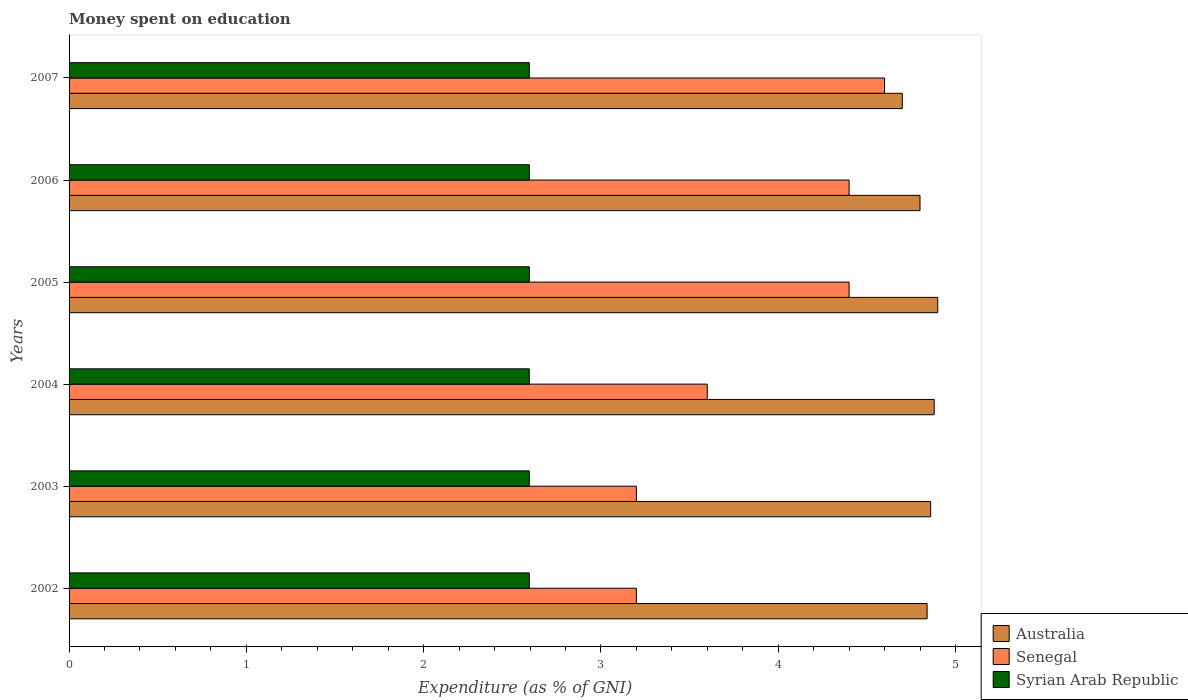How many different coloured bars are there?
Ensure brevity in your answer.  3. Are the number of bars per tick equal to the number of legend labels?
Your answer should be compact. Yes. How many bars are there on the 5th tick from the top?
Ensure brevity in your answer.  3. How many bars are there on the 5th tick from the bottom?
Keep it short and to the point. 3. In how many cases, is the number of bars for a given year not equal to the number of legend labels?
Keep it short and to the point. 0. What is the amount of money spent on education in Syrian Arab Republic in 2004?
Keep it short and to the point. 2.6. Across all years, what is the maximum amount of money spent on education in Australia?
Make the answer very short. 4.9. Across all years, what is the minimum amount of money spent on education in Syrian Arab Republic?
Offer a terse response. 2.6. In which year was the amount of money spent on education in Australia maximum?
Keep it short and to the point. 2005. What is the total amount of money spent on education in Australia in the graph?
Ensure brevity in your answer.  28.98. What is the difference between the amount of money spent on education in Senegal in 2004 and that in 2006?
Provide a succinct answer. -0.8. What is the average amount of money spent on education in Syrian Arab Republic per year?
Your answer should be compact. 2.6. In the year 2004, what is the difference between the amount of money spent on education in Syrian Arab Republic and amount of money spent on education in Australia?
Your answer should be compact. -2.28. What is the ratio of the amount of money spent on education in Senegal in 2003 to that in 2004?
Provide a short and direct response. 0.89. What is the difference between the highest and the second highest amount of money spent on education in Australia?
Your answer should be compact. 0.02. What is the difference between the highest and the lowest amount of money spent on education in Australia?
Provide a short and direct response. 0.2. What does the 2nd bar from the top in 2003 represents?
Provide a succinct answer. Senegal. What does the 2nd bar from the bottom in 2004 represents?
Your response must be concise. Senegal. Are all the bars in the graph horizontal?
Offer a terse response. Yes. How many years are there in the graph?
Give a very brief answer. 6. What is the difference between two consecutive major ticks on the X-axis?
Your response must be concise. 1. Are the values on the major ticks of X-axis written in scientific E-notation?
Provide a short and direct response. No. Does the graph contain grids?
Make the answer very short. No. Where does the legend appear in the graph?
Your answer should be compact. Bottom right. How many legend labels are there?
Offer a very short reply. 3. How are the legend labels stacked?
Provide a succinct answer. Vertical. What is the title of the graph?
Provide a short and direct response. Money spent on education. What is the label or title of the X-axis?
Give a very brief answer. Expenditure (as % of GNI). What is the Expenditure (as % of GNI) of Australia in 2002?
Provide a short and direct response. 4.84. What is the Expenditure (as % of GNI) in Senegal in 2002?
Your answer should be very brief. 3.2. What is the Expenditure (as % of GNI) in Syrian Arab Republic in 2002?
Your answer should be very brief. 2.6. What is the Expenditure (as % of GNI) of Australia in 2003?
Keep it short and to the point. 4.86. What is the Expenditure (as % of GNI) of Syrian Arab Republic in 2003?
Offer a very short reply. 2.6. What is the Expenditure (as % of GNI) in Australia in 2004?
Your answer should be compact. 4.88. What is the Expenditure (as % of GNI) in Senegal in 2004?
Provide a succinct answer. 3.6. What is the Expenditure (as % of GNI) of Syrian Arab Republic in 2004?
Make the answer very short. 2.6. What is the Expenditure (as % of GNI) of Australia in 2005?
Your answer should be very brief. 4.9. What is the Expenditure (as % of GNI) of Senegal in 2005?
Keep it short and to the point. 4.4. What is the Expenditure (as % of GNI) of Syrian Arab Republic in 2005?
Ensure brevity in your answer.  2.6. What is the Expenditure (as % of GNI) in Australia in 2006?
Provide a succinct answer. 4.8. What is the Expenditure (as % of GNI) in Senegal in 2006?
Offer a terse response. 4.4. What is the Expenditure (as % of GNI) in Syrian Arab Republic in 2006?
Offer a very short reply. 2.6. What is the Expenditure (as % of GNI) of Senegal in 2007?
Ensure brevity in your answer.  4.6. What is the Expenditure (as % of GNI) of Syrian Arab Republic in 2007?
Ensure brevity in your answer.  2.6. Across all years, what is the maximum Expenditure (as % of GNI) of Australia?
Offer a very short reply. 4.9. Across all years, what is the maximum Expenditure (as % of GNI) of Senegal?
Provide a short and direct response. 4.6. Across all years, what is the maximum Expenditure (as % of GNI) in Syrian Arab Republic?
Provide a succinct answer. 2.6. Across all years, what is the minimum Expenditure (as % of GNI) in Australia?
Your response must be concise. 4.7. Across all years, what is the minimum Expenditure (as % of GNI) of Syrian Arab Republic?
Make the answer very short. 2.6. What is the total Expenditure (as % of GNI) in Australia in the graph?
Provide a succinct answer. 28.98. What is the total Expenditure (as % of GNI) in Senegal in the graph?
Your answer should be compact. 23.4. What is the total Expenditure (as % of GNI) of Syrian Arab Republic in the graph?
Offer a terse response. 15.58. What is the difference between the Expenditure (as % of GNI) in Australia in 2002 and that in 2003?
Offer a very short reply. -0.02. What is the difference between the Expenditure (as % of GNI) of Senegal in 2002 and that in 2003?
Ensure brevity in your answer.  0. What is the difference between the Expenditure (as % of GNI) in Syrian Arab Republic in 2002 and that in 2003?
Your answer should be compact. 0. What is the difference between the Expenditure (as % of GNI) in Australia in 2002 and that in 2004?
Offer a terse response. -0.04. What is the difference between the Expenditure (as % of GNI) in Senegal in 2002 and that in 2004?
Your answer should be compact. -0.4. What is the difference between the Expenditure (as % of GNI) in Syrian Arab Republic in 2002 and that in 2004?
Keep it short and to the point. 0. What is the difference between the Expenditure (as % of GNI) of Australia in 2002 and that in 2005?
Your response must be concise. -0.06. What is the difference between the Expenditure (as % of GNI) in Australia in 2002 and that in 2006?
Make the answer very short. 0.04. What is the difference between the Expenditure (as % of GNI) of Senegal in 2002 and that in 2006?
Make the answer very short. -1.2. What is the difference between the Expenditure (as % of GNI) in Australia in 2002 and that in 2007?
Your answer should be compact. 0.14. What is the difference between the Expenditure (as % of GNI) in Senegal in 2002 and that in 2007?
Ensure brevity in your answer.  -1.4. What is the difference between the Expenditure (as % of GNI) of Australia in 2003 and that in 2004?
Your response must be concise. -0.02. What is the difference between the Expenditure (as % of GNI) of Senegal in 2003 and that in 2004?
Provide a succinct answer. -0.4. What is the difference between the Expenditure (as % of GNI) in Australia in 2003 and that in 2005?
Ensure brevity in your answer.  -0.04. What is the difference between the Expenditure (as % of GNI) of Syrian Arab Republic in 2003 and that in 2005?
Give a very brief answer. 0. What is the difference between the Expenditure (as % of GNI) of Australia in 2003 and that in 2006?
Ensure brevity in your answer.  0.06. What is the difference between the Expenditure (as % of GNI) of Syrian Arab Republic in 2003 and that in 2006?
Offer a very short reply. 0. What is the difference between the Expenditure (as % of GNI) in Australia in 2003 and that in 2007?
Make the answer very short. 0.16. What is the difference between the Expenditure (as % of GNI) of Australia in 2004 and that in 2005?
Ensure brevity in your answer.  -0.02. What is the difference between the Expenditure (as % of GNI) of Australia in 2004 and that in 2006?
Make the answer very short. 0.08. What is the difference between the Expenditure (as % of GNI) of Senegal in 2004 and that in 2006?
Give a very brief answer. -0.8. What is the difference between the Expenditure (as % of GNI) in Syrian Arab Republic in 2004 and that in 2006?
Give a very brief answer. 0. What is the difference between the Expenditure (as % of GNI) of Australia in 2004 and that in 2007?
Provide a short and direct response. 0.18. What is the difference between the Expenditure (as % of GNI) in Senegal in 2004 and that in 2007?
Provide a short and direct response. -1. What is the difference between the Expenditure (as % of GNI) in Syrian Arab Republic in 2005 and that in 2007?
Your answer should be very brief. 0. What is the difference between the Expenditure (as % of GNI) of Australia in 2006 and that in 2007?
Make the answer very short. 0.1. What is the difference between the Expenditure (as % of GNI) in Senegal in 2006 and that in 2007?
Offer a terse response. -0.2. What is the difference between the Expenditure (as % of GNI) in Australia in 2002 and the Expenditure (as % of GNI) in Senegal in 2003?
Provide a short and direct response. 1.64. What is the difference between the Expenditure (as % of GNI) of Australia in 2002 and the Expenditure (as % of GNI) of Syrian Arab Republic in 2003?
Your response must be concise. 2.24. What is the difference between the Expenditure (as % of GNI) of Senegal in 2002 and the Expenditure (as % of GNI) of Syrian Arab Republic in 2003?
Ensure brevity in your answer.  0.6. What is the difference between the Expenditure (as % of GNI) of Australia in 2002 and the Expenditure (as % of GNI) of Senegal in 2004?
Offer a very short reply. 1.24. What is the difference between the Expenditure (as % of GNI) in Australia in 2002 and the Expenditure (as % of GNI) in Syrian Arab Republic in 2004?
Keep it short and to the point. 2.24. What is the difference between the Expenditure (as % of GNI) in Senegal in 2002 and the Expenditure (as % of GNI) in Syrian Arab Republic in 2004?
Make the answer very short. 0.6. What is the difference between the Expenditure (as % of GNI) of Australia in 2002 and the Expenditure (as % of GNI) of Senegal in 2005?
Ensure brevity in your answer.  0.44. What is the difference between the Expenditure (as % of GNI) of Australia in 2002 and the Expenditure (as % of GNI) of Syrian Arab Republic in 2005?
Your answer should be compact. 2.24. What is the difference between the Expenditure (as % of GNI) of Senegal in 2002 and the Expenditure (as % of GNI) of Syrian Arab Republic in 2005?
Your answer should be very brief. 0.6. What is the difference between the Expenditure (as % of GNI) in Australia in 2002 and the Expenditure (as % of GNI) in Senegal in 2006?
Your answer should be compact. 0.44. What is the difference between the Expenditure (as % of GNI) in Australia in 2002 and the Expenditure (as % of GNI) in Syrian Arab Republic in 2006?
Provide a succinct answer. 2.24. What is the difference between the Expenditure (as % of GNI) in Senegal in 2002 and the Expenditure (as % of GNI) in Syrian Arab Republic in 2006?
Offer a very short reply. 0.6. What is the difference between the Expenditure (as % of GNI) in Australia in 2002 and the Expenditure (as % of GNI) in Senegal in 2007?
Offer a terse response. 0.24. What is the difference between the Expenditure (as % of GNI) of Australia in 2002 and the Expenditure (as % of GNI) of Syrian Arab Republic in 2007?
Make the answer very short. 2.24. What is the difference between the Expenditure (as % of GNI) of Senegal in 2002 and the Expenditure (as % of GNI) of Syrian Arab Republic in 2007?
Give a very brief answer. 0.6. What is the difference between the Expenditure (as % of GNI) in Australia in 2003 and the Expenditure (as % of GNI) in Senegal in 2004?
Keep it short and to the point. 1.26. What is the difference between the Expenditure (as % of GNI) of Australia in 2003 and the Expenditure (as % of GNI) of Syrian Arab Republic in 2004?
Make the answer very short. 2.26. What is the difference between the Expenditure (as % of GNI) in Senegal in 2003 and the Expenditure (as % of GNI) in Syrian Arab Republic in 2004?
Your answer should be compact. 0.6. What is the difference between the Expenditure (as % of GNI) in Australia in 2003 and the Expenditure (as % of GNI) in Senegal in 2005?
Offer a very short reply. 0.46. What is the difference between the Expenditure (as % of GNI) in Australia in 2003 and the Expenditure (as % of GNI) in Syrian Arab Republic in 2005?
Keep it short and to the point. 2.26. What is the difference between the Expenditure (as % of GNI) of Senegal in 2003 and the Expenditure (as % of GNI) of Syrian Arab Republic in 2005?
Offer a very short reply. 0.6. What is the difference between the Expenditure (as % of GNI) in Australia in 2003 and the Expenditure (as % of GNI) in Senegal in 2006?
Your answer should be very brief. 0.46. What is the difference between the Expenditure (as % of GNI) of Australia in 2003 and the Expenditure (as % of GNI) of Syrian Arab Republic in 2006?
Offer a terse response. 2.26. What is the difference between the Expenditure (as % of GNI) of Senegal in 2003 and the Expenditure (as % of GNI) of Syrian Arab Republic in 2006?
Keep it short and to the point. 0.6. What is the difference between the Expenditure (as % of GNI) of Australia in 2003 and the Expenditure (as % of GNI) of Senegal in 2007?
Offer a very short reply. 0.26. What is the difference between the Expenditure (as % of GNI) in Australia in 2003 and the Expenditure (as % of GNI) in Syrian Arab Republic in 2007?
Offer a terse response. 2.26. What is the difference between the Expenditure (as % of GNI) in Senegal in 2003 and the Expenditure (as % of GNI) in Syrian Arab Republic in 2007?
Ensure brevity in your answer.  0.6. What is the difference between the Expenditure (as % of GNI) of Australia in 2004 and the Expenditure (as % of GNI) of Senegal in 2005?
Ensure brevity in your answer.  0.48. What is the difference between the Expenditure (as % of GNI) in Australia in 2004 and the Expenditure (as % of GNI) in Syrian Arab Republic in 2005?
Give a very brief answer. 2.28. What is the difference between the Expenditure (as % of GNI) in Senegal in 2004 and the Expenditure (as % of GNI) in Syrian Arab Republic in 2005?
Offer a terse response. 1. What is the difference between the Expenditure (as % of GNI) in Australia in 2004 and the Expenditure (as % of GNI) in Senegal in 2006?
Your answer should be very brief. 0.48. What is the difference between the Expenditure (as % of GNI) in Australia in 2004 and the Expenditure (as % of GNI) in Syrian Arab Republic in 2006?
Provide a short and direct response. 2.28. What is the difference between the Expenditure (as % of GNI) of Senegal in 2004 and the Expenditure (as % of GNI) of Syrian Arab Republic in 2006?
Your response must be concise. 1. What is the difference between the Expenditure (as % of GNI) of Australia in 2004 and the Expenditure (as % of GNI) of Senegal in 2007?
Provide a short and direct response. 0.28. What is the difference between the Expenditure (as % of GNI) in Australia in 2004 and the Expenditure (as % of GNI) in Syrian Arab Republic in 2007?
Provide a short and direct response. 2.28. What is the difference between the Expenditure (as % of GNI) of Senegal in 2004 and the Expenditure (as % of GNI) of Syrian Arab Republic in 2007?
Give a very brief answer. 1. What is the difference between the Expenditure (as % of GNI) in Australia in 2005 and the Expenditure (as % of GNI) in Senegal in 2006?
Make the answer very short. 0.5. What is the difference between the Expenditure (as % of GNI) of Australia in 2005 and the Expenditure (as % of GNI) of Syrian Arab Republic in 2006?
Give a very brief answer. 2.3. What is the difference between the Expenditure (as % of GNI) in Senegal in 2005 and the Expenditure (as % of GNI) in Syrian Arab Republic in 2006?
Offer a terse response. 1.8. What is the difference between the Expenditure (as % of GNI) of Australia in 2005 and the Expenditure (as % of GNI) of Syrian Arab Republic in 2007?
Provide a succinct answer. 2.3. What is the difference between the Expenditure (as % of GNI) of Senegal in 2005 and the Expenditure (as % of GNI) of Syrian Arab Republic in 2007?
Ensure brevity in your answer.  1.8. What is the difference between the Expenditure (as % of GNI) in Australia in 2006 and the Expenditure (as % of GNI) in Senegal in 2007?
Provide a succinct answer. 0.2. What is the difference between the Expenditure (as % of GNI) of Australia in 2006 and the Expenditure (as % of GNI) of Syrian Arab Republic in 2007?
Your response must be concise. 2.2. What is the difference between the Expenditure (as % of GNI) in Senegal in 2006 and the Expenditure (as % of GNI) in Syrian Arab Republic in 2007?
Ensure brevity in your answer.  1.8. What is the average Expenditure (as % of GNI) of Australia per year?
Your answer should be very brief. 4.83. What is the average Expenditure (as % of GNI) in Syrian Arab Republic per year?
Provide a short and direct response. 2.6. In the year 2002, what is the difference between the Expenditure (as % of GNI) of Australia and Expenditure (as % of GNI) of Senegal?
Make the answer very short. 1.64. In the year 2002, what is the difference between the Expenditure (as % of GNI) in Australia and Expenditure (as % of GNI) in Syrian Arab Republic?
Your answer should be compact. 2.24. In the year 2002, what is the difference between the Expenditure (as % of GNI) in Senegal and Expenditure (as % of GNI) in Syrian Arab Republic?
Offer a very short reply. 0.6. In the year 2003, what is the difference between the Expenditure (as % of GNI) in Australia and Expenditure (as % of GNI) in Senegal?
Your answer should be very brief. 1.66. In the year 2003, what is the difference between the Expenditure (as % of GNI) of Australia and Expenditure (as % of GNI) of Syrian Arab Republic?
Your response must be concise. 2.26. In the year 2003, what is the difference between the Expenditure (as % of GNI) in Senegal and Expenditure (as % of GNI) in Syrian Arab Republic?
Provide a succinct answer. 0.6. In the year 2004, what is the difference between the Expenditure (as % of GNI) in Australia and Expenditure (as % of GNI) in Senegal?
Provide a succinct answer. 1.28. In the year 2004, what is the difference between the Expenditure (as % of GNI) of Australia and Expenditure (as % of GNI) of Syrian Arab Republic?
Offer a terse response. 2.28. In the year 2005, what is the difference between the Expenditure (as % of GNI) in Australia and Expenditure (as % of GNI) in Syrian Arab Republic?
Offer a terse response. 2.3. In the year 2005, what is the difference between the Expenditure (as % of GNI) in Senegal and Expenditure (as % of GNI) in Syrian Arab Republic?
Your answer should be compact. 1.8. In the year 2006, what is the difference between the Expenditure (as % of GNI) of Australia and Expenditure (as % of GNI) of Syrian Arab Republic?
Keep it short and to the point. 2.2. In the year 2006, what is the difference between the Expenditure (as % of GNI) in Senegal and Expenditure (as % of GNI) in Syrian Arab Republic?
Keep it short and to the point. 1.8. In the year 2007, what is the difference between the Expenditure (as % of GNI) of Australia and Expenditure (as % of GNI) of Syrian Arab Republic?
Your response must be concise. 2.1. In the year 2007, what is the difference between the Expenditure (as % of GNI) of Senegal and Expenditure (as % of GNI) of Syrian Arab Republic?
Ensure brevity in your answer.  2. What is the ratio of the Expenditure (as % of GNI) in Syrian Arab Republic in 2002 to that in 2003?
Your response must be concise. 1. What is the ratio of the Expenditure (as % of GNI) in Senegal in 2002 to that in 2004?
Ensure brevity in your answer.  0.89. What is the ratio of the Expenditure (as % of GNI) of Syrian Arab Republic in 2002 to that in 2004?
Give a very brief answer. 1. What is the ratio of the Expenditure (as % of GNI) in Australia in 2002 to that in 2005?
Your answer should be compact. 0.99. What is the ratio of the Expenditure (as % of GNI) of Senegal in 2002 to that in 2005?
Ensure brevity in your answer.  0.73. What is the ratio of the Expenditure (as % of GNI) in Syrian Arab Republic in 2002 to that in 2005?
Your answer should be compact. 1. What is the ratio of the Expenditure (as % of GNI) in Australia in 2002 to that in 2006?
Make the answer very short. 1.01. What is the ratio of the Expenditure (as % of GNI) of Senegal in 2002 to that in 2006?
Keep it short and to the point. 0.73. What is the ratio of the Expenditure (as % of GNI) of Australia in 2002 to that in 2007?
Give a very brief answer. 1.03. What is the ratio of the Expenditure (as % of GNI) of Senegal in 2002 to that in 2007?
Provide a short and direct response. 0.7. What is the ratio of the Expenditure (as % of GNI) of Australia in 2003 to that in 2005?
Offer a very short reply. 0.99. What is the ratio of the Expenditure (as % of GNI) of Senegal in 2003 to that in 2005?
Your answer should be compact. 0.73. What is the ratio of the Expenditure (as % of GNI) of Australia in 2003 to that in 2006?
Make the answer very short. 1.01. What is the ratio of the Expenditure (as % of GNI) of Senegal in 2003 to that in 2006?
Give a very brief answer. 0.73. What is the ratio of the Expenditure (as % of GNI) in Australia in 2003 to that in 2007?
Your answer should be compact. 1.03. What is the ratio of the Expenditure (as % of GNI) of Senegal in 2003 to that in 2007?
Keep it short and to the point. 0.7. What is the ratio of the Expenditure (as % of GNI) in Syrian Arab Republic in 2003 to that in 2007?
Offer a terse response. 1. What is the ratio of the Expenditure (as % of GNI) in Australia in 2004 to that in 2005?
Your answer should be very brief. 1. What is the ratio of the Expenditure (as % of GNI) in Senegal in 2004 to that in 2005?
Make the answer very short. 0.82. What is the ratio of the Expenditure (as % of GNI) in Australia in 2004 to that in 2006?
Your answer should be compact. 1.02. What is the ratio of the Expenditure (as % of GNI) in Senegal in 2004 to that in 2006?
Your answer should be compact. 0.82. What is the ratio of the Expenditure (as % of GNI) in Syrian Arab Republic in 2004 to that in 2006?
Offer a very short reply. 1. What is the ratio of the Expenditure (as % of GNI) of Australia in 2004 to that in 2007?
Ensure brevity in your answer.  1.04. What is the ratio of the Expenditure (as % of GNI) of Senegal in 2004 to that in 2007?
Your answer should be compact. 0.78. What is the ratio of the Expenditure (as % of GNI) in Australia in 2005 to that in 2006?
Provide a succinct answer. 1.02. What is the ratio of the Expenditure (as % of GNI) in Syrian Arab Republic in 2005 to that in 2006?
Your response must be concise. 1. What is the ratio of the Expenditure (as % of GNI) in Australia in 2005 to that in 2007?
Give a very brief answer. 1.04. What is the ratio of the Expenditure (as % of GNI) in Senegal in 2005 to that in 2007?
Your answer should be compact. 0.96. What is the ratio of the Expenditure (as % of GNI) of Australia in 2006 to that in 2007?
Your response must be concise. 1.02. What is the ratio of the Expenditure (as % of GNI) in Senegal in 2006 to that in 2007?
Your answer should be very brief. 0.96. What is the difference between the highest and the second highest Expenditure (as % of GNI) in Australia?
Provide a short and direct response. 0.02. What is the difference between the highest and the second highest Expenditure (as % of GNI) in Syrian Arab Republic?
Keep it short and to the point. 0. What is the difference between the highest and the lowest Expenditure (as % of GNI) of Syrian Arab Republic?
Give a very brief answer. 0. 